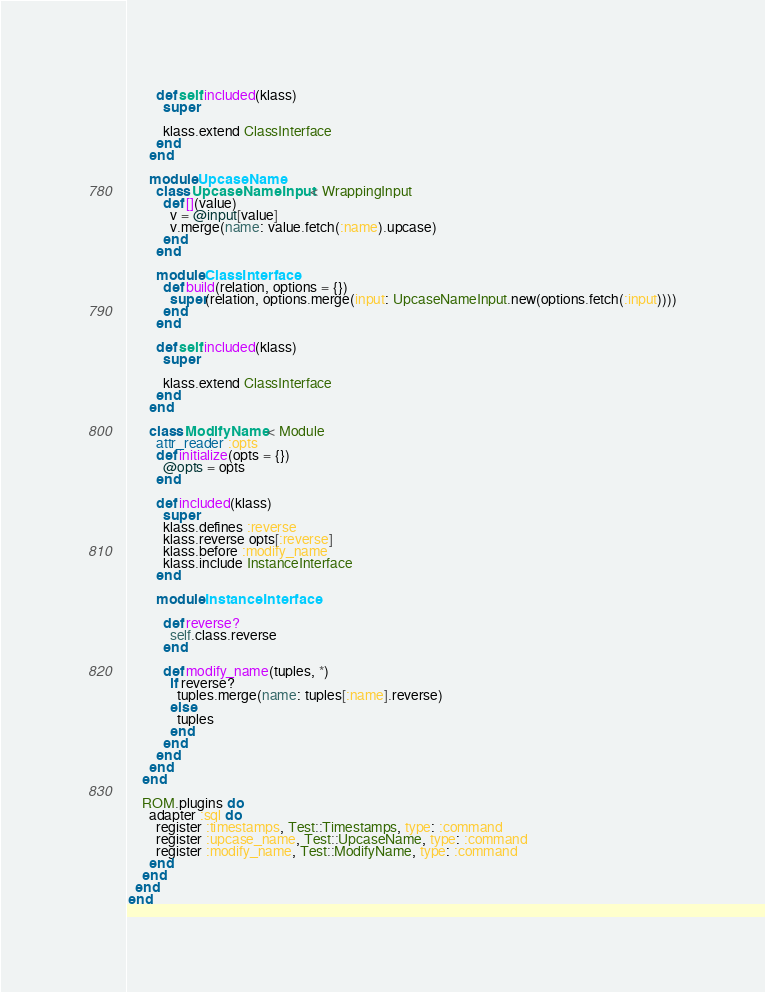<code> <loc_0><loc_0><loc_500><loc_500><_Ruby_>        def self.included(klass)
          super

          klass.extend ClassInterface
        end
      end

      module UpcaseName
        class UpcaseNameInput < WrappingInput
          def [](value)
            v = @input[value]
            v.merge(name: value.fetch(:name).upcase)
          end
        end

        module ClassInterface
          def build(relation, options = {})
            super(relation, options.merge(input: UpcaseNameInput.new(options.fetch(:input))))
          end
        end

        def self.included(klass)
          super

          klass.extend ClassInterface
        end
      end

      class ModifyName < Module
        attr_reader :opts
        def initialize(opts = {})
          @opts = opts
        end

        def included(klass)
          super
          klass.defines :reverse
          klass.reverse opts[:reverse]
          klass.before :modify_name
          klass.include InstanceInterface
        end

        module InstanceInterface

          def reverse?
            self.class.reverse
          end

          def modify_name(tuples, *)
            if reverse?
              tuples.merge(name: tuples[:name].reverse)
            else
              tuples
            end
          end
        end
      end
    end

    ROM.plugins do
      adapter :sql do
        register :timestamps, Test::Timestamps, type: :command
        register :upcase_name, Test::UpcaseName, type: :command
        register :modify_name, Test::ModifyName, type: :command
      end
    end
  end
end
</code> 